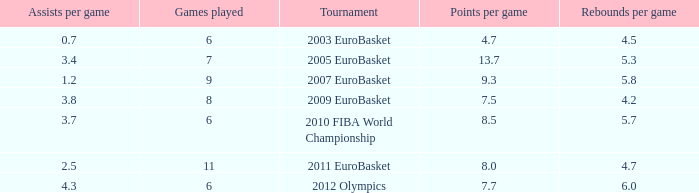How many assists per game in the tournament 2010 fiba world championship? 3.7. 